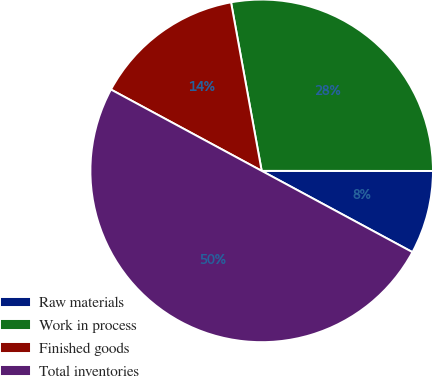Convert chart to OTSL. <chart><loc_0><loc_0><loc_500><loc_500><pie_chart><fcel>Raw materials<fcel>Work in process<fcel>Finished goods<fcel>Total inventories<nl><fcel>7.86%<fcel>27.87%<fcel>14.26%<fcel>50.0%<nl></chart> 